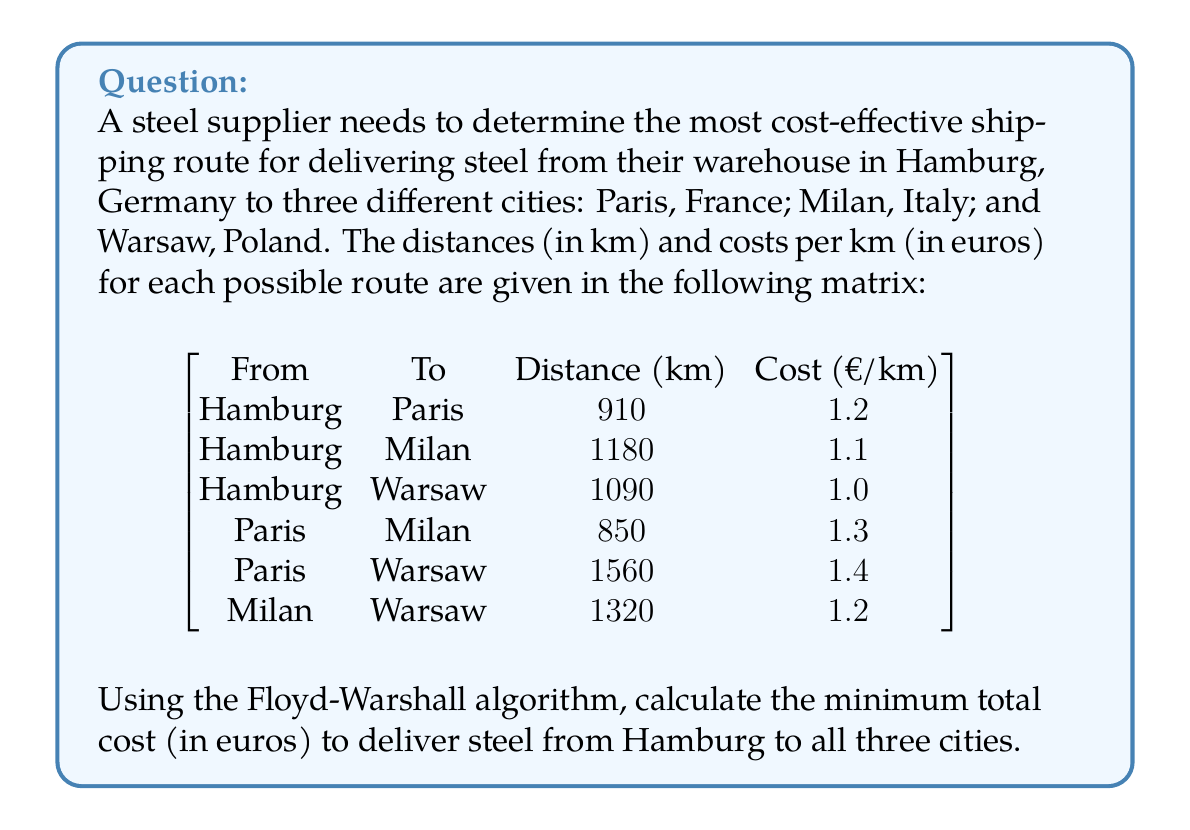Give your solution to this math problem. To solve this problem, we'll use the Floyd-Warshall algorithm to find the shortest (least costly) path between all pairs of cities. Then, we'll determine the minimum spanning tree to connect all cities.

Step 1: Initialize the cost matrix
Let's create a 4x4 matrix representing the costs between cities:
$$
C = \begin{bmatrix}
0 & 1092 & 1298 & 1090 \\
1092 & 0 & 1105 & 2184 \\
1298 & 1105 & 0 & 1584 \\
1090 & 2184 & 1584 & 0
\end{bmatrix}
$$
Where the cities are ordered: Hamburg (H), Paris (P), Milan (M), Warsaw (W).

Step 2: Apply the Floyd-Warshall algorithm
For k = 1 to 4, i = 1 to 4, j = 1 to 4:
$$C_{ij} = \min(C_{ij}, C_{ik} + C_{kj})$$

After applying the algorithm, we get the final cost matrix:
$$
C = \begin{bmatrix}
0 & 1092 & 1298 & 1090 \\
1092 & 0 & 1105 & 2182 \\
1298 & 1105 & 0 & 1584 \\
1090 & 2182 & 1584 & 0
\end{bmatrix}
$$

Step 3: Find the minimum spanning tree
To connect all cities with the minimum total cost, we need to find the minimum spanning tree. We can use Kruskal's algorithm:

1. Hamburg to Warsaw: 1090€
2. Hamburg to Paris: 1092€
3. Paris to Milan: 1105€

Step 4: Calculate the total cost
Total cost = 1090 + 1092 + 1105 = 3287€

Therefore, the minimum total cost to deliver steel from Hamburg to all three cities is 3287€.
Answer: 3287€ 